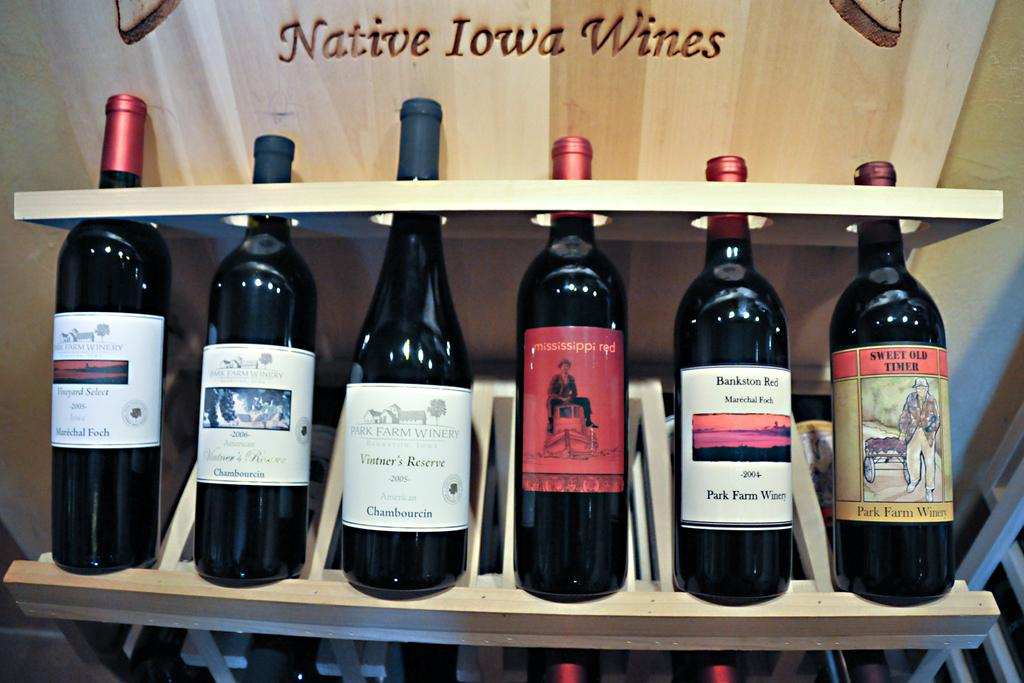<image>
Write a terse but informative summary of the picture. Several bottles of on are on a shelf behind a sign proclaiming them Native Iowa Wines. 